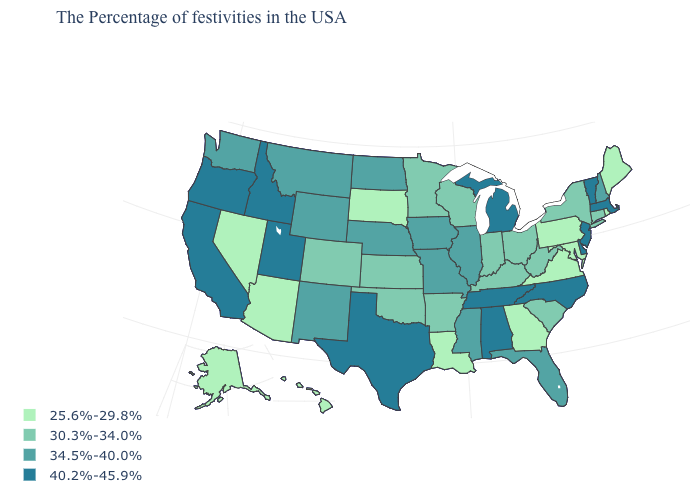Which states have the highest value in the USA?
Give a very brief answer. Massachusetts, Vermont, New Jersey, Delaware, North Carolina, Michigan, Alabama, Tennessee, Texas, Utah, Idaho, California, Oregon. What is the value of South Carolina?
Concise answer only. 30.3%-34.0%. Among the states that border Maryland , does Virginia have the lowest value?
Write a very short answer. Yes. What is the value of Rhode Island?
Concise answer only. 25.6%-29.8%. How many symbols are there in the legend?
Answer briefly. 4. How many symbols are there in the legend?
Give a very brief answer. 4. Name the states that have a value in the range 40.2%-45.9%?
Answer briefly. Massachusetts, Vermont, New Jersey, Delaware, North Carolina, Michigan, Alabama, Tennessee, Texas, Utah, Idaho, California, Oregon. What is the highest value in the MidWest ?
Concise answer only. 40.2%-45.9%. Which states hav the highest value in the MidWest?
Write a very short answer. Michigan. Name the states that have a value in the range 40.2%-45.9%?
Keep it brief. Massachusetts, Vermont, New Jersey, Delaware, North Carolina, Michigan, Alabama, Tennessee, Texas, Utah, Idaho, California, Oregon. What is the value of Indiana?
Answer briefly. 30.3%-34.0%. Is the legend a continuous bar?
Give a very brief answer. No. Does Arizona have a lower value than New York?
Keep it brief. Yes. Does Michigan have the highest value in the USA?
Give a very brief answer. Yes. Name the states that have a value in the range 30.3%-34.0%?
Keep it brief. Connecticut, New York, South Carolina, West Virginia, Ohio, Kentucky, Indiana, Wisconsin, Arkansas, Minnesota, Kansas, Oklahoma, Colorado. 